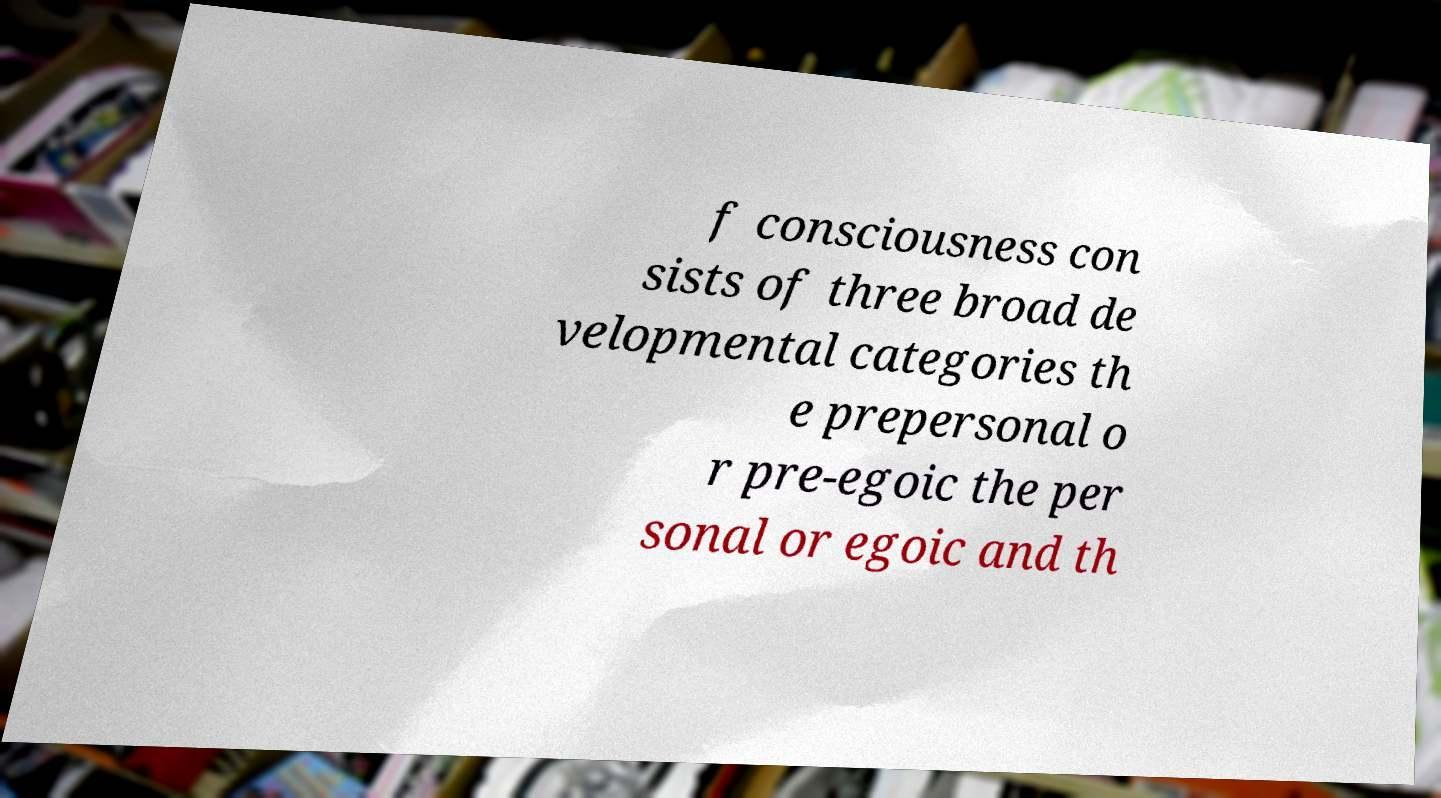There's text embedded in this image that I need extracted. Can you transcribe it verbatim? f consciousness con sists of three broad de velopmental categories th e prepersonal o r pre-egoic the per sonal or egoic and th 